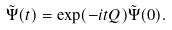<formula> <loc_0><loc_0><loc_500><loc_500>\tilde { \Psi } ( t ) = \exp ( - i t Q ) \tilde { \Psi } ( 0 ) .</formula> 